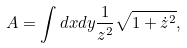Convert formula to latex. <formula><loc_0><loc_0><loc_500><loc_500>A = \int d x d y \frac { 1 } { z ^ { 2 } } \sqrt { 1 + \dot { z } ^ { 2 } } ,</formula> 